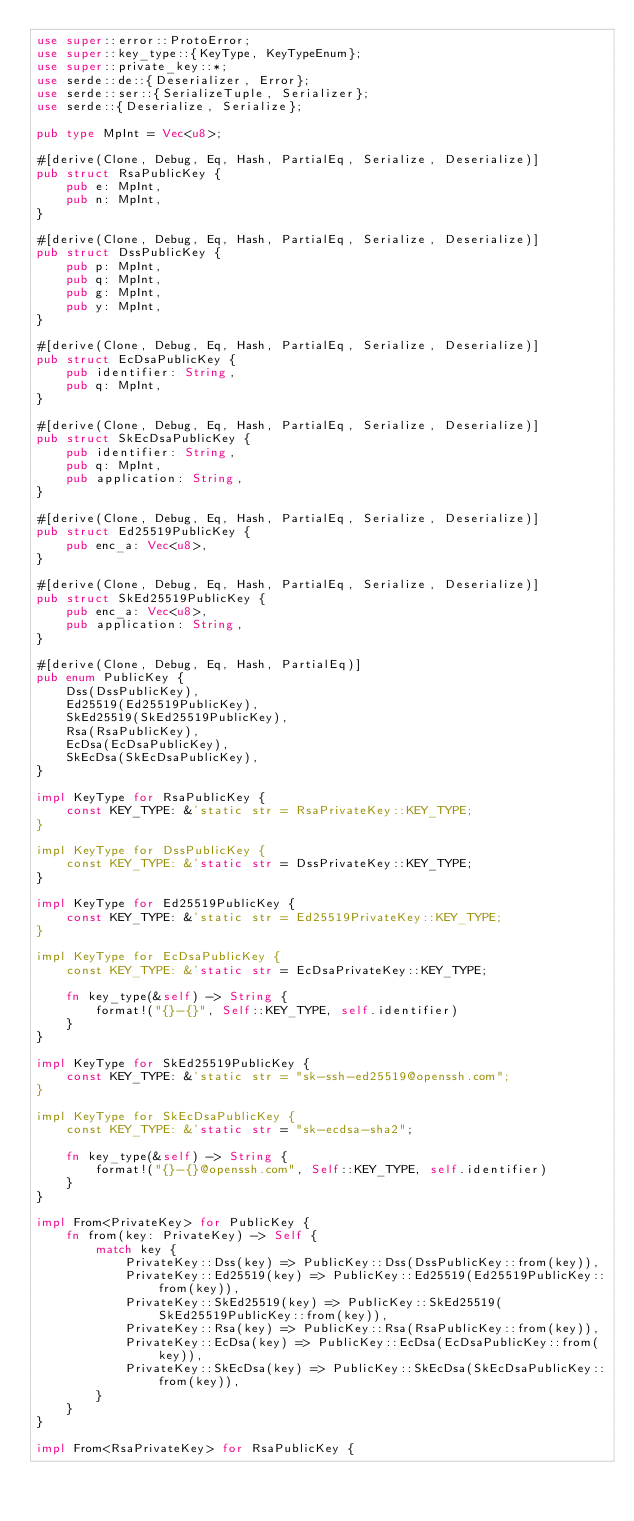<code> <loc_0><loc_0><loc_500><loc_500><_Rust_>use super::error::ProtoError;
use super::key_type::{KeyType, KeyTypeEnum};
use super::private_key::*;
use serde::de::{Deserializer, Error};
use serde::ser::{SerializeTuple, Serializer};
use serde::{Deserialize, Serialize};

pub type MpInt = Vec<u8>;

#[derive(Clone, Debug, Eq, Hash, PartialEq, Serialize, Deserialize)]
pub struct RsaPublicKey {
    pub e: MpInt,
    pub n: MpInt,
}

#[derive(Clone, Debug, Eq, Hash, PartialEq, Serialize, Deserialize)]
pub struct DssPublicKey {
    pub p: MpInt,
    pub q: MpInt,
    pub g: MpInt,
    pub y: MpInt,
}

#[derive(Clone, Debug, Eq, Hash, PartialEq, Serialize, Deserialize)]
pub struct EcDsaPublicKey {
    pub identifier: String,
    pub q: MpInt,
}

#[derive(Clone, Debug, Eq, Hash, PartialEq, Serialize, Deserialize)]
pub struct SkEcDsaPublicKey {
    pub identifier: String,
    pub q: MpInt,
    pub application: String,
}

#[derive(Clone, Debug, Eq, Hash, PartialEq, Serialize, Deserialize)]
pub struct Ed25519PublicKey {
    pub enc_a: Vec<u8>,
}

#[derive(Clone, Debug, Eq, Hash, PartialEq, Serialize, Deserialize)]
pub struct SkEd25519PublicKey {
    pub enc_a: Vec<u8>,
    pub application: String,
}

#[derive(Clone, Debug, Eq, Hash, PartialEq)]
pub enum PublicKey {
    Dss(DssPublicKey),
    Ed25519(Ed25519PublicKey),
    SkEd25519(SkEd25519PublicKey),
    Rsa(RsaPublicKey),
    EcDsa(EcDsaPublicKey),
    SkEcDsa(SkEcDsaPublicKey),
}

impl KeyType for RsaPublicKey {
    const KEY_TYPE: &'static str = RsaPrivateKey::KEY_TYPE;
}

impl KeyType for DssPublicKey {
    const KEY_TYPE: &'static str = DssPrivateKey::KEY_TYPE;
}

impl KeyType for Ed25519PublicKey {
    const KEY_TYPE: &'static str = Ed25519PrivateKey::KEY_TYPE;
}

impl KeyType for EcDsaPublicKey {
    const KEY_TYPE: &'static str = EcDsaPrivateKey::KEY_TYPE;

    fn key_type(&self) -> String {
        format!("{}-{}", Self::KEY_TYPE, self.identifier)
    }
}

impl KeyType for SkEd25519PublicKey {
    const KEY_TYPE: &'static str = "sk-ssh-ed25519@openssh.com";
}

impl KeyType for SkEcDsaPublicKey {
    const KEY_TYPE: &'static str = "sk-ecdsa-sha2";

    fn key_type(&self) -> String {
        format!("{}-{}@openssh.com", Self::KEY_TYPE, self.identifier)
    }
}

impl From<PrivateKey> for PublicKey {
    fn from(key: PrivateKey) -> Self {
        match key {
            PrivateKey::Dss(key) => PublicKey::Dss(DssPublicKey::from(key)),
            PrivateKey::Ed25519(key) => PublicKey::Ed25519(Ed25519PublicKey::from(key)),
            PrivateKey::SkEd25519(key) => PublicKey::SkEd25519(SkEd25519PublicKey::from(key)),
            PrivateKey::Rsa(key) => PublicKey::Rsa(RsaPublicKey::from(key)),
            PrivateKey::EcDsa(key) => PublicKey::EcDsa(EcDsaPublicKey::from(key)),
            PrivateKey::SkEcDsa(key) => PublicKey::SkEcDsa(SkEcDsaPublicKey::from(key)),
        }
    }
}

impl From<RsaPrivateKey> for RsaPublicKey {</code> 